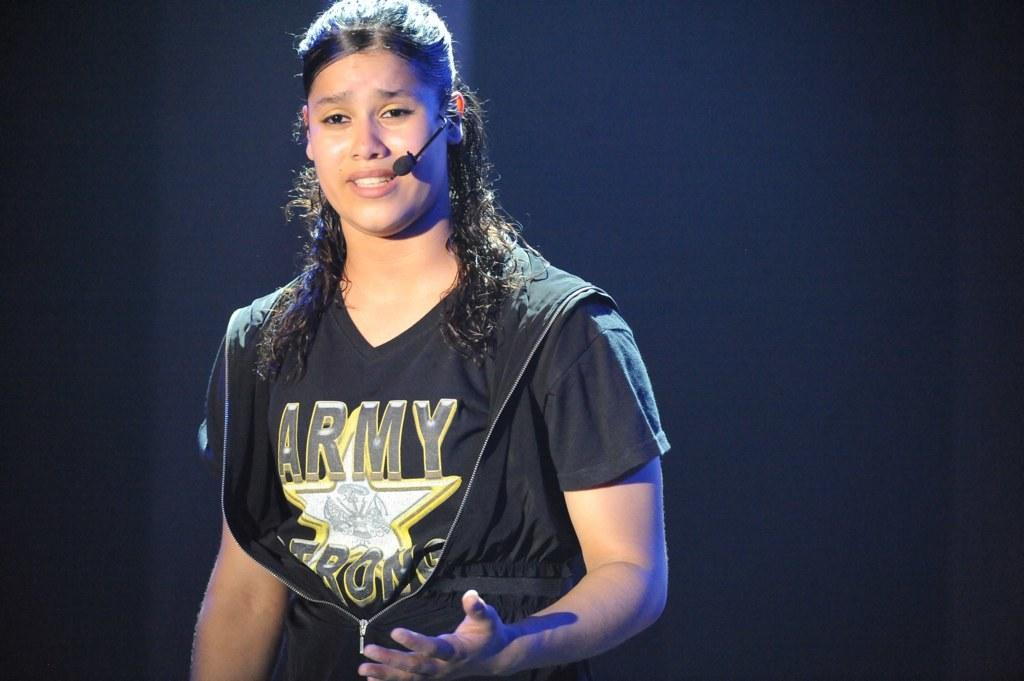<image>
Render a clear and concise summary of the photo. A lady with a microphone is wearing a black Army Strong t-shirt. 